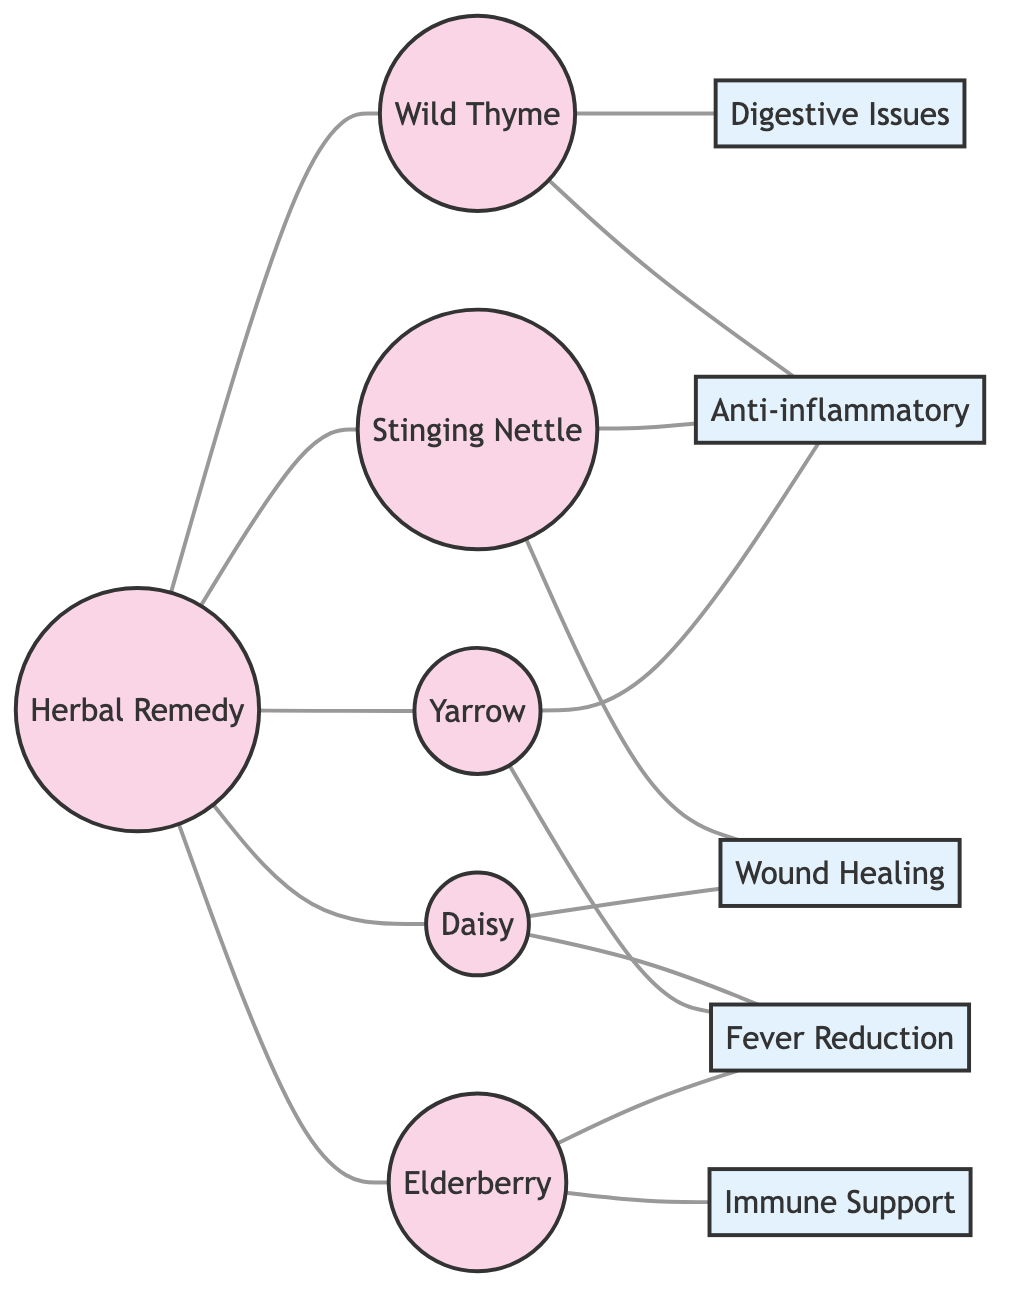What is the total number of herbal remedies shown in the diagram? The diagram lists 5 herbal remedies: Wild Thyme, Stinging Nettle, Daisy, Yarrow, and Elderberry. Counting these gives a total of 5.
Answer: 5 Which herbal remedy is connected to "Digestive Issues"? The herbal remedy connected to "Digestive Issues" is Wild Thyme. This can be seen by following the edge from Wild Thyme to Digestive Issues.
Answer: Wild Thyme How many edges are connecting the herbal remedies to their uses? There are 13 edges connecting the herbal remedies to their uses. This is determined by counting each line connecting a remedy to a use on the diagram.
Answer: 13 Which herbal remedy has the most connections to uses? The herbal remedy Yarrow has the most connections, specifically to Fever Reduction and Anti-inflammatory uses. Counting the lines leads to the conclusion that it connects to 3 uses total.
Answer: Yarrow What is the relationship between "Elderberry" and "Immune Support"? Elderberry is directly connected to Immune Support, as indicated by a line linking the two nodes in the diagram, showing that Elderberry is used for Immune Support.
Answer: Directly connected 